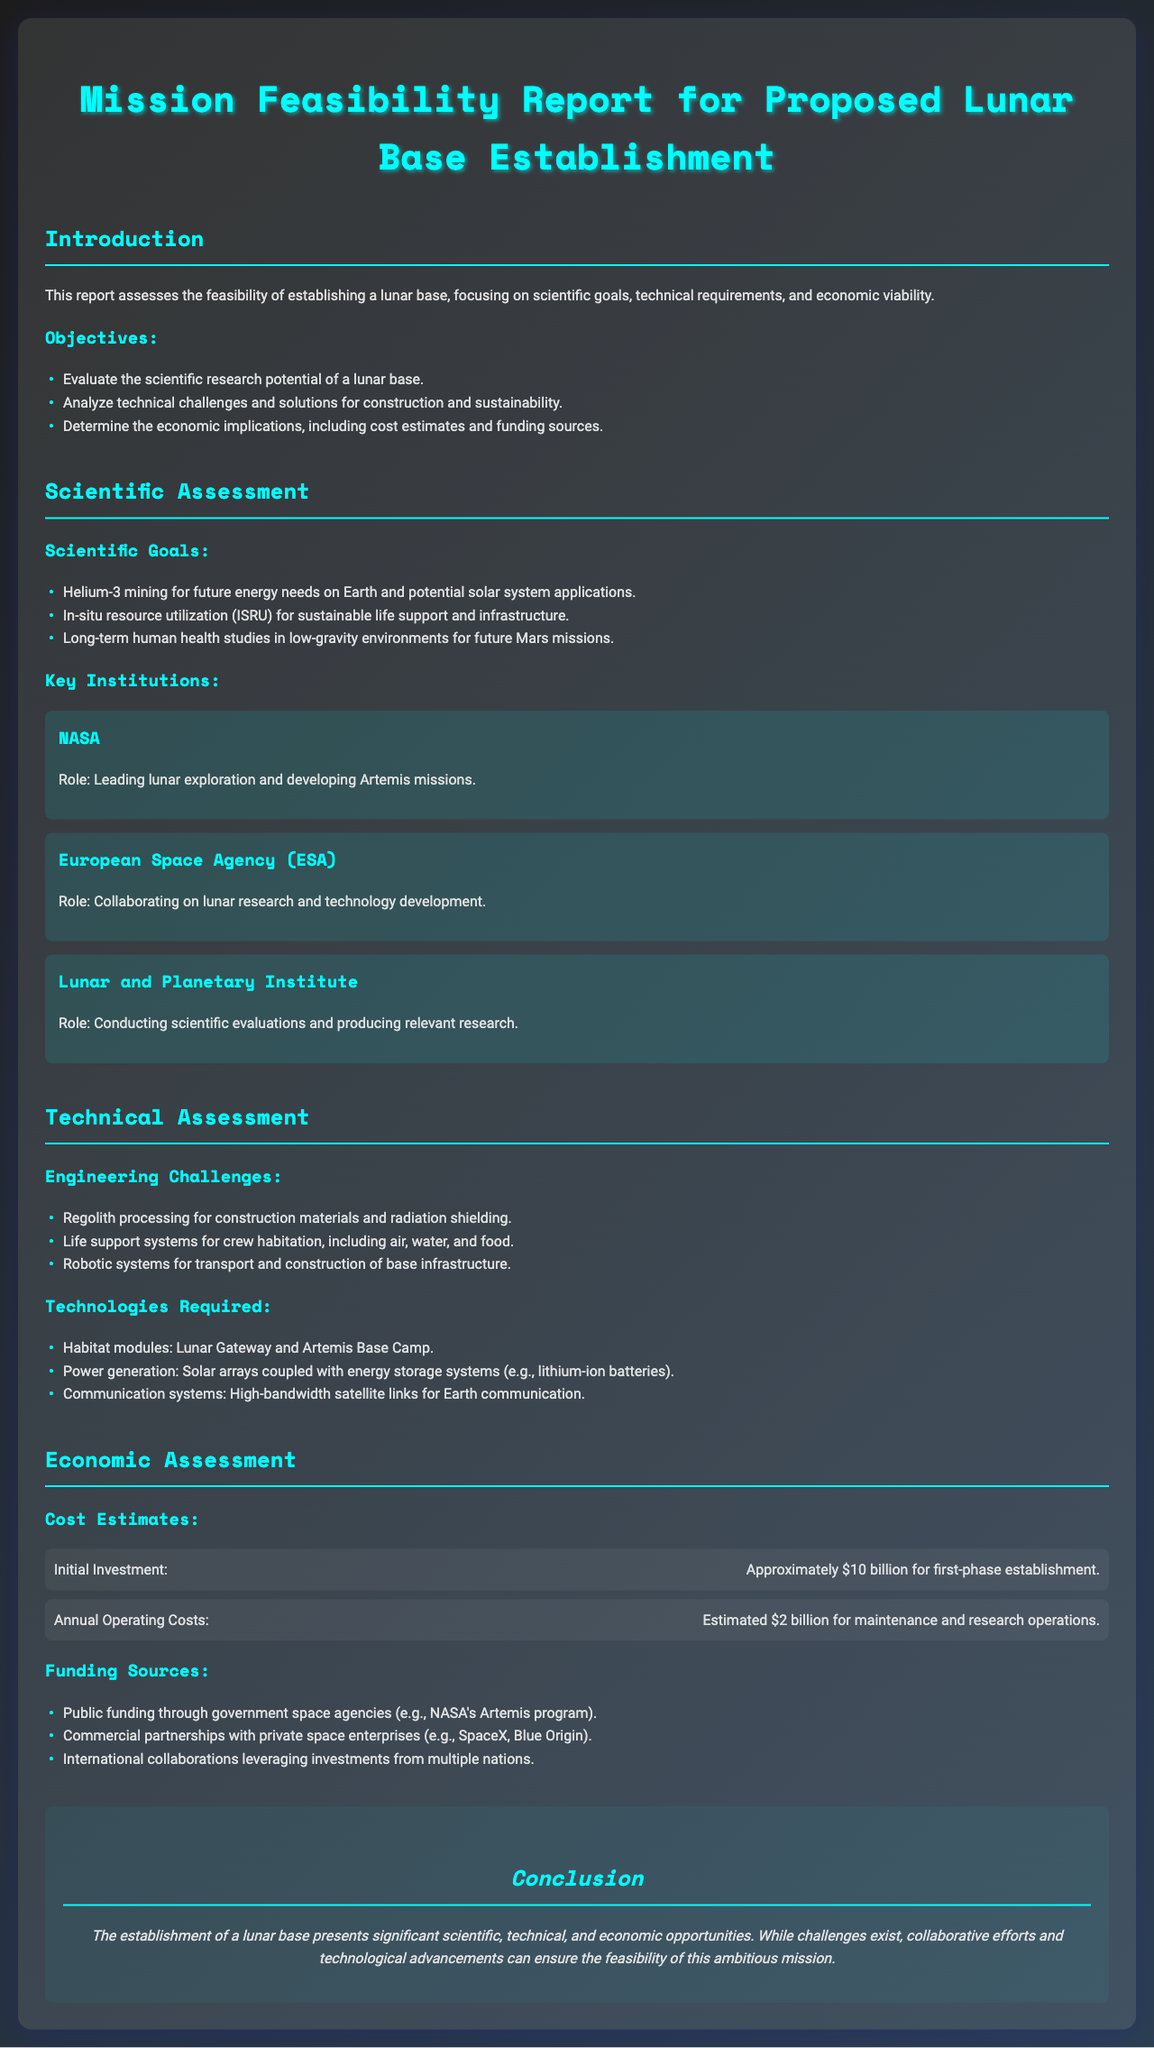What is the primary focus of the report? The report assesses the feasibility of establishing a lunar base, specifically addressing scientific, technical, and economic factors.
Answer: Establishing a lunar base What is the estimated initial investment for the lunar base? The document states that the approximate initial investment required for the first-phase establishment is $10 billion.
Answer: $10 billion Which organization is leading lunar exploration? The report identifies NASA as the organization leading lunar exploration and developing Artemis missions.
Answer: NASA What are the annual operating costs estimated at? The document estimates the annual operating costs for maintenance and research operations to be $2 billion.
Answer: $2 billion Name a scientific goal mentioned in the report. The report lists Helium-3 mining for future energy needs on Earth as a scientific goal.
Answer: Helium-3 mining What is one engineering challenge for the lunar base? The report mentions regolith processing for construction materials and radiation shielding as an engineering challenge.
Answer: Regolith processing Which institutions are involved in lunar research and technology development? The report mentions the European Space Agency (ESA) as collaborating on lunar research and technology development.
Answer: European Space Agency (ESA) What type of system is required for crew habitation? The report states that life support systems for crew habitation, including air, water, and food, are required.
Answer: Life support systems What is a funding source for the lunar base? The document lists public funding through government space agencies, like NASA's Artemis program, as a funding source.
Answer: Public funding through government space agencies What is the conclusion of the report? The conclusion states that the establishment of a lunar base presents significant opportunities despite challenges, hinging on collaborative efforts and technology.
Answer: Significant opportunities 